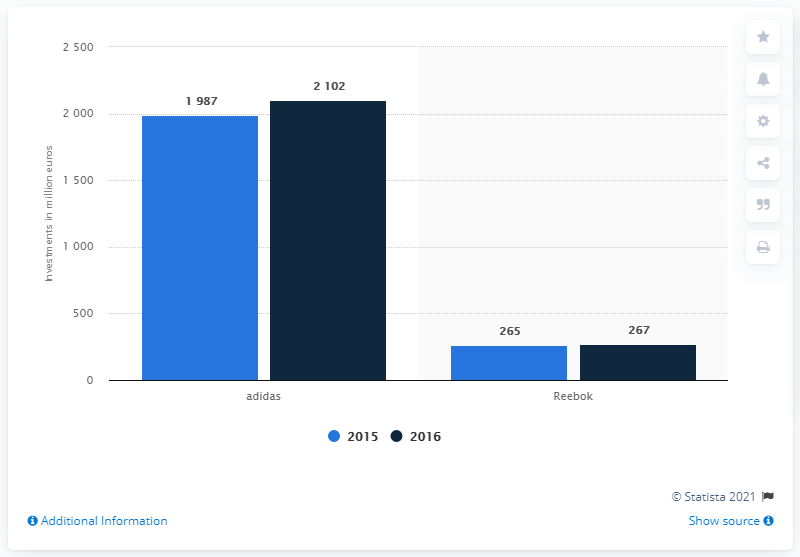Give some essential details in this illustration. In 2015, the Adidas brand was different from its 2016 version. The brand that invested the most in point-of-sale and marketing in both years was adidas. Adidas spent $265 million marketing its Reebok brand in 2016. 